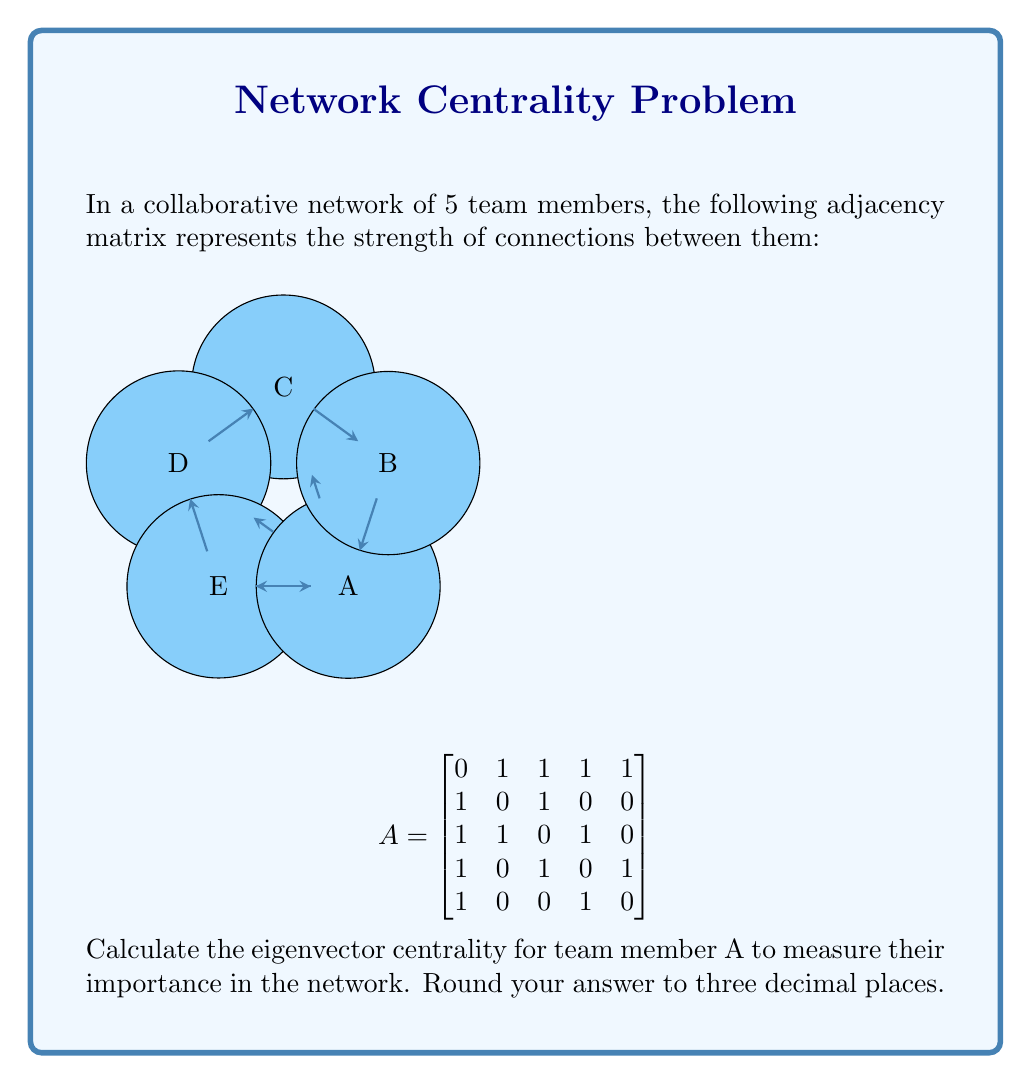What is the answer to this math problem? To calculate the eigenvector centrality for team member A, we need to follow these steps:

1) First, we need to find the largest eigenvalue (λ) and its corresponding eigenvector for the adjacency matrix A.

2) The characteristic equation is:
   $$det(A - λI) = 0$$

3) Solving this equation gives us the largest eigenvalue: λ ≈ 2.4815

4) Now, we need to find the eigenvector v that satisfies:
   $$(A - λI)v = 0$$

5) Solving this system of equations and normalizing the result, we get the eigenvector:
   $$v ≈ \begin{bmatrix} 0.5774 \\ 0.2944 \\ 0.4472 \\ 0.4472 \\ 0.2944 \end{bmatrix}$$

6) The eigenvector centrality for each node is given by the corresponding component in this eigenvector.

7) For team member A, this is the first component of the eigenvector: 0.5774

8) Rounding to three decimal places: 0.577

This value indicates that team member A has the highest centrality in the network, suggesting they play a crucial role in team collaboration.
Answer: 0.577 